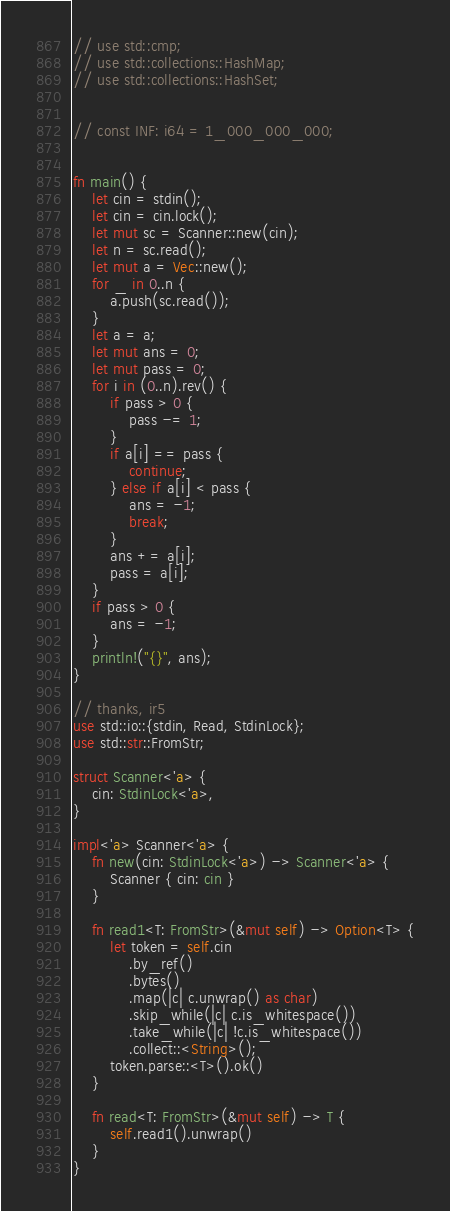Convert code to text. <code><loc_0><loc_0><loc_500><loc_500><_Rust_>// use std::cmp;
// use std::collections::HashMap;
// use std::collections::HashSet;


// const INF: i64 = 1_000_000_000;


fn main() {
    let cin = stdin();
    let cin = cin.lock();
    let mut sc = Scanner::new(cin);
    let n = sc.read();
    let mut a = Vec::new();
    for _ in 0..n {
        a.push(sc.read());
    }
    let a = a;
    let mut ans = 0;
    let mut pass = 0;
    for i in (0..n).rev() {
        if pass > 0 {
            pass -= 1;
        }
        if a[i] == pass {
            continue;
        } else if a[i] < pass {
            ans = -1;
            break;
        }
        ans += a[i];
        pass = a[i];
    }
    if pass > 0 {
        ans = -1;
    }
    println!("{}", ans);
}

// thanks, ir5
use std::io::{stdin, Read, StdinLock};
use std::str::FromStr;

struct Scanner<'a> {
    cin: StdinLock<'a>,
}

impl<'a> Scanner<'a> {
    fn new(cin: StdinLock<'a>) -> Scanner<'a> {
        Scanner { cin: cin }
    }

    fn read1<T: FromStr>(&mut self) -> Option<T> {
        let token = self.cin
            .by_ref()
            .bytes()
            .map(|c| c.unwrap() as char)
            .skip_while(|c| c.is_whitespace())
            .take_while(|c| !c.is_whitespace())
            .collect::<String>();
        token.parse::<T>().ok()
    }

    fn read<T: FromStr>(&mut self) -> T {
        self.read1().unwrap()
    }
}
</code> 